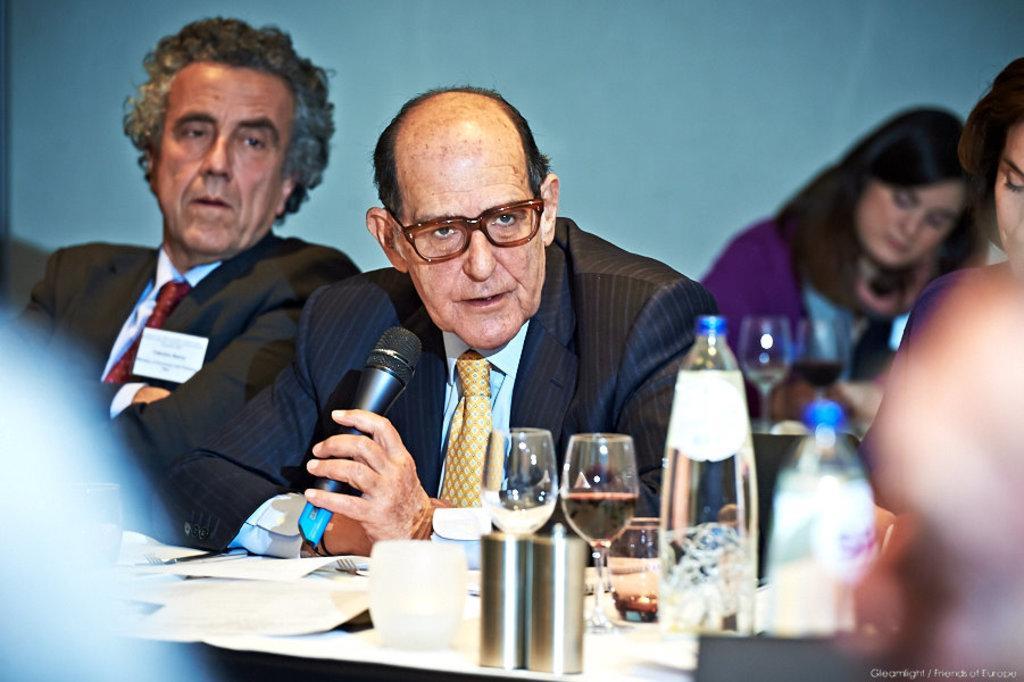How would you summarize this image in a sentence or two? In this image I can see few people are sitting in-front of the table. These people are wearing the blazers and some people with different color dresses. I can see one person is holding the mic. On the table I can see glasses, bottles and plates. In the back I can see the blue wall. 